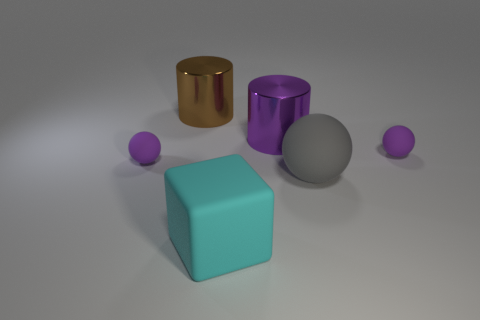Add 2 rubber things. How many objects exist? 8 Subtract all purple rubber spheres. How many spheres are left? 1 Subtract all gray spheres. How many spheres are left? 2 Subtract all brown spheres. How many brown cubes are left? 0 Subtract all big brown objects. Subtract all big purple metallic cylinders. How many objects are left? 4 Add 5 small things. How many small things are left? 7 Add 4 cyan rubber cubes. How many cyan rubber cubes exist? 5 Subtract 0 brown balls. How many objects are left? 6 Subtract all cylinders. How many objects are left? 4 Subtract 1 balls. How many balls are left? 2 